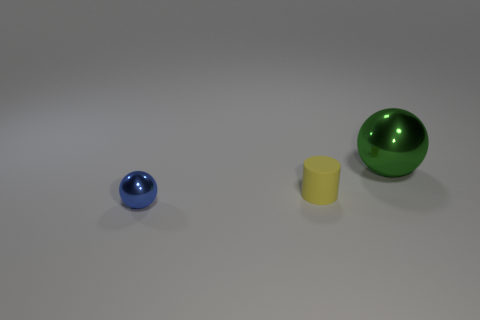Add 3 blue metal things. How many objects exist? 6 Subtract all green balls. How many balls are left? 1 Subtract all brown cylinders. Subtract all blue cubes. How many cylinders are left? 1 Add 2 tiny yellow cylinders. How many tiny yellow cylinders exist? 3 Subtract 0 gray balls. How many objects are left? 3 Subtract all spheres. How many objects are left? 1 Subtract all things. Subtract all small cyan shiny cylinders. How many objects are left? 0 Add 3 matte cylinders. How many matte cylinders are left? 4 